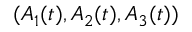Convert formula to latex. <formula><loc_0><loc_0><loc_500><loc_500>( A _ { 1 } ( t ) , A _ { 2 } ( t ) , A _ { 3 } ( t ) )</formula> 